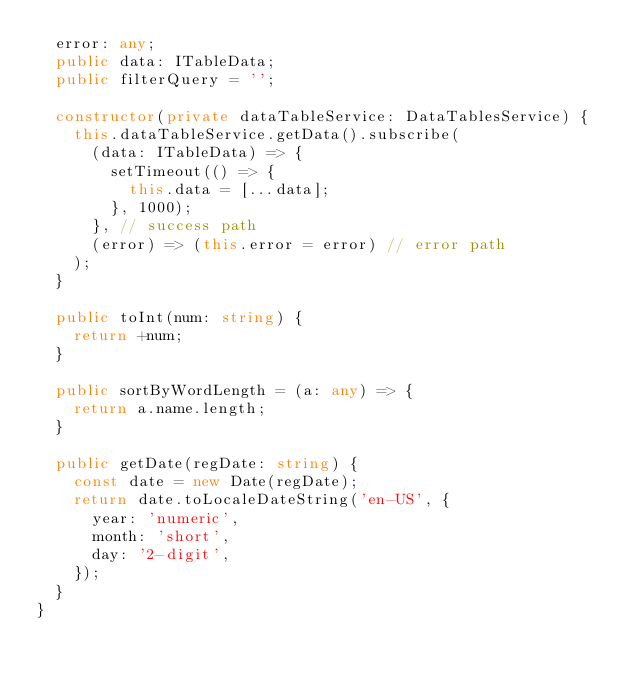Convert code to text. <code><loc_0><loc_0><loc_500><loc_500><_TypeScript_>  error: any;
  public data: ITableData;
  public filterQuery = '';

  constructor(private dataTableService: DataTablesService) {
    this.dataTableService.getData().subscribe(
      (data: ITableData) => {
        setTimeout(() => {
          this.data = [...data];
        }, 1000);
      }, // success path
      (error) => (this.error = error) // error path
    );
  }

  public toInt(num: string) {
    return +num;
  }

  public sortByWordLength = (a: any) => {
    return a.name.length;
  }

  public getDate(regDate: string) {
    const date = new Date(regDate);
    return date.toLocaleDateString('en-US', {
      year: 'numeric',
      month: 'short',
      day: '2-digit',
    });
  }
}
</code> 